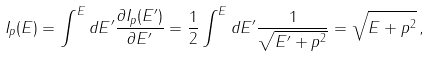Convert formula to latex. <formula><loc_0><loc_0><loc_500><loc_500>I _ { p } ( E ) = \int ^ { E } d E ^ { \prime } \frac { \partial I _ { p } ( E ^ { \prime } ) } { \partial E ^ { \prime } } = \frac { 1 } { 2 } \int ^ { E } d E ^ { \prime } \frac { 1 } { \sqrt { E ^ { \prime } + p ^ { 2 } } } = \sqrt { E + p ^ { 2 } } \, ,</formula> 